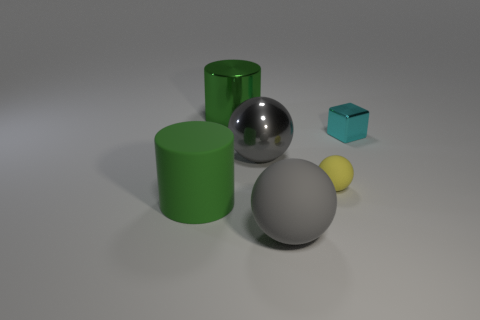How many things are either big gray balls or gray balls in front of the matte cylinder?
Offer a very short reply. 2. The matte sphere behind the green cylinder that is in front of the cyan metal object is what color?
Offer a very short reply. Yellow. There is a big metal thing that is in front of the cyan metallic cube; is it the same color as the large matte sphere?
Make the answer very short. Yes. There is a big green object behind the cyan metallic object; what is its material?
Offer a terse response. Metal. The gray metal object has what size?
Your response must be concise. Large. Is the material of the green object in front of the tiny cyan object the same as the yellow object?
Your answer should be compact. Yes. How many big gray rubber things are there?
Offer a very short reply. 1. How many objects are small cyan cubes or tiny blue metallic balls?
Your answer should be compact. 1. There is a large gray sphere behind the tiny matte sphere on the left side of the cyan metallic cube; how many yellow matte objects are left of it?
Your response must be concise. 0. Are there any other things of the same color as the small rubber sphere?
Provide a short and direct response. No. 